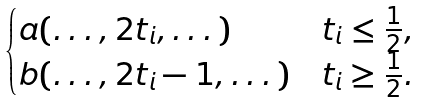<formula> <loc_0><loc_0><loc_500><loc_500>\begin{cases} a ( \dots , 2 t _ { i } , \dots ) & t _ { i } \leq \frac { 1 } { 2 } , \\ b ( \dots , 2 t _ { i } - 1 , \dots ) & t _ { i } \geq \frac { 1 } { 2 } . \end{cases}</formula> 